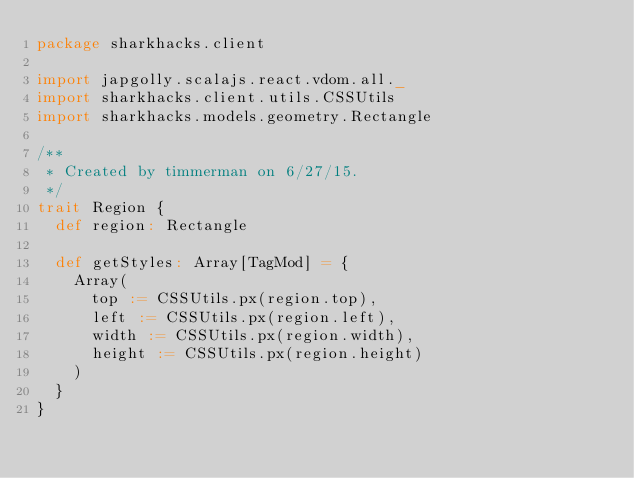Convert code to text. <code><loc_0><loc_0><loc_500><loc_500><_Scala_>package sharkhacks.client

import japgolly.scalajs.react.vdom.all._
import sharkhacks.client.utils.CSSUtils
import sharkhacks.models.geometry.Rectangle

/**
 * Created by timmerman on 6/27/15.
 */
trait Region {
  def region: Rectangle

  def getStyles: Array[TagMod] = {
    Array(
      top := CSSUtils.px(region.top),
      left := CSSUtils.px(region.left),
      width := CSSUtils.px(region.width),
      height := CSSUtils.px(region.height)
    )
  }
}
</code> 